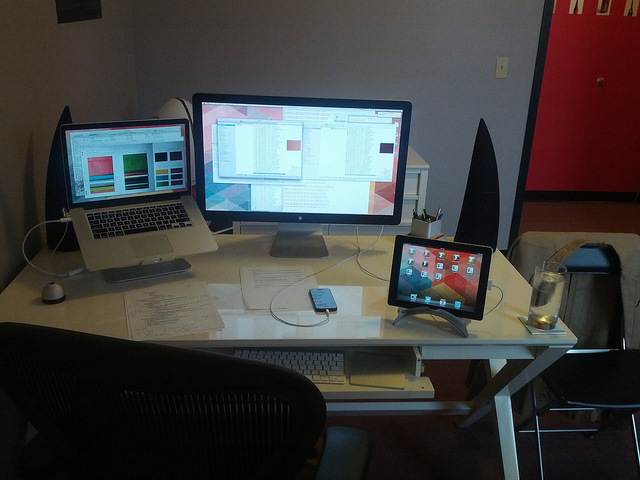Can you tell me what might be the purpose of the setup on this desk? The desk setup appears geared towards productivity, likely for tasks that require multiple screens, such as programming, design work, or video editing. The presence of an iPad suggests the user might also engage in tasks that benefit from a touch interface, such as drawing or reading.  Are there any items on the desk that indicate this might be a home office? Yes, there are personal items like a water glass and some papers which could imply a more casual, home office setting. The lack of more formal office decor and the presence of a wall decoration also support this hypothesis. 